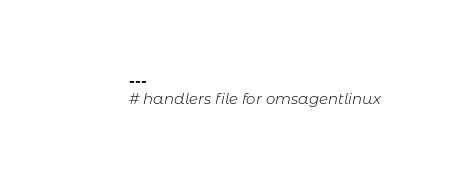<code> <loc_0><loc_0><loc_500><loc_500><_YAML_>---
# handlers file for omsagentlinux</code> 